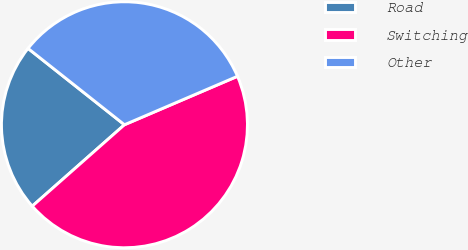<chart> <loc_0><loc_0><loc_500><loc_500><pie_chart><fcel>Road<fcel>Switching<fcel>Other<nl><fcel>22.17%<fcel>44.93%<fcel>32.89%<nl></chart> 